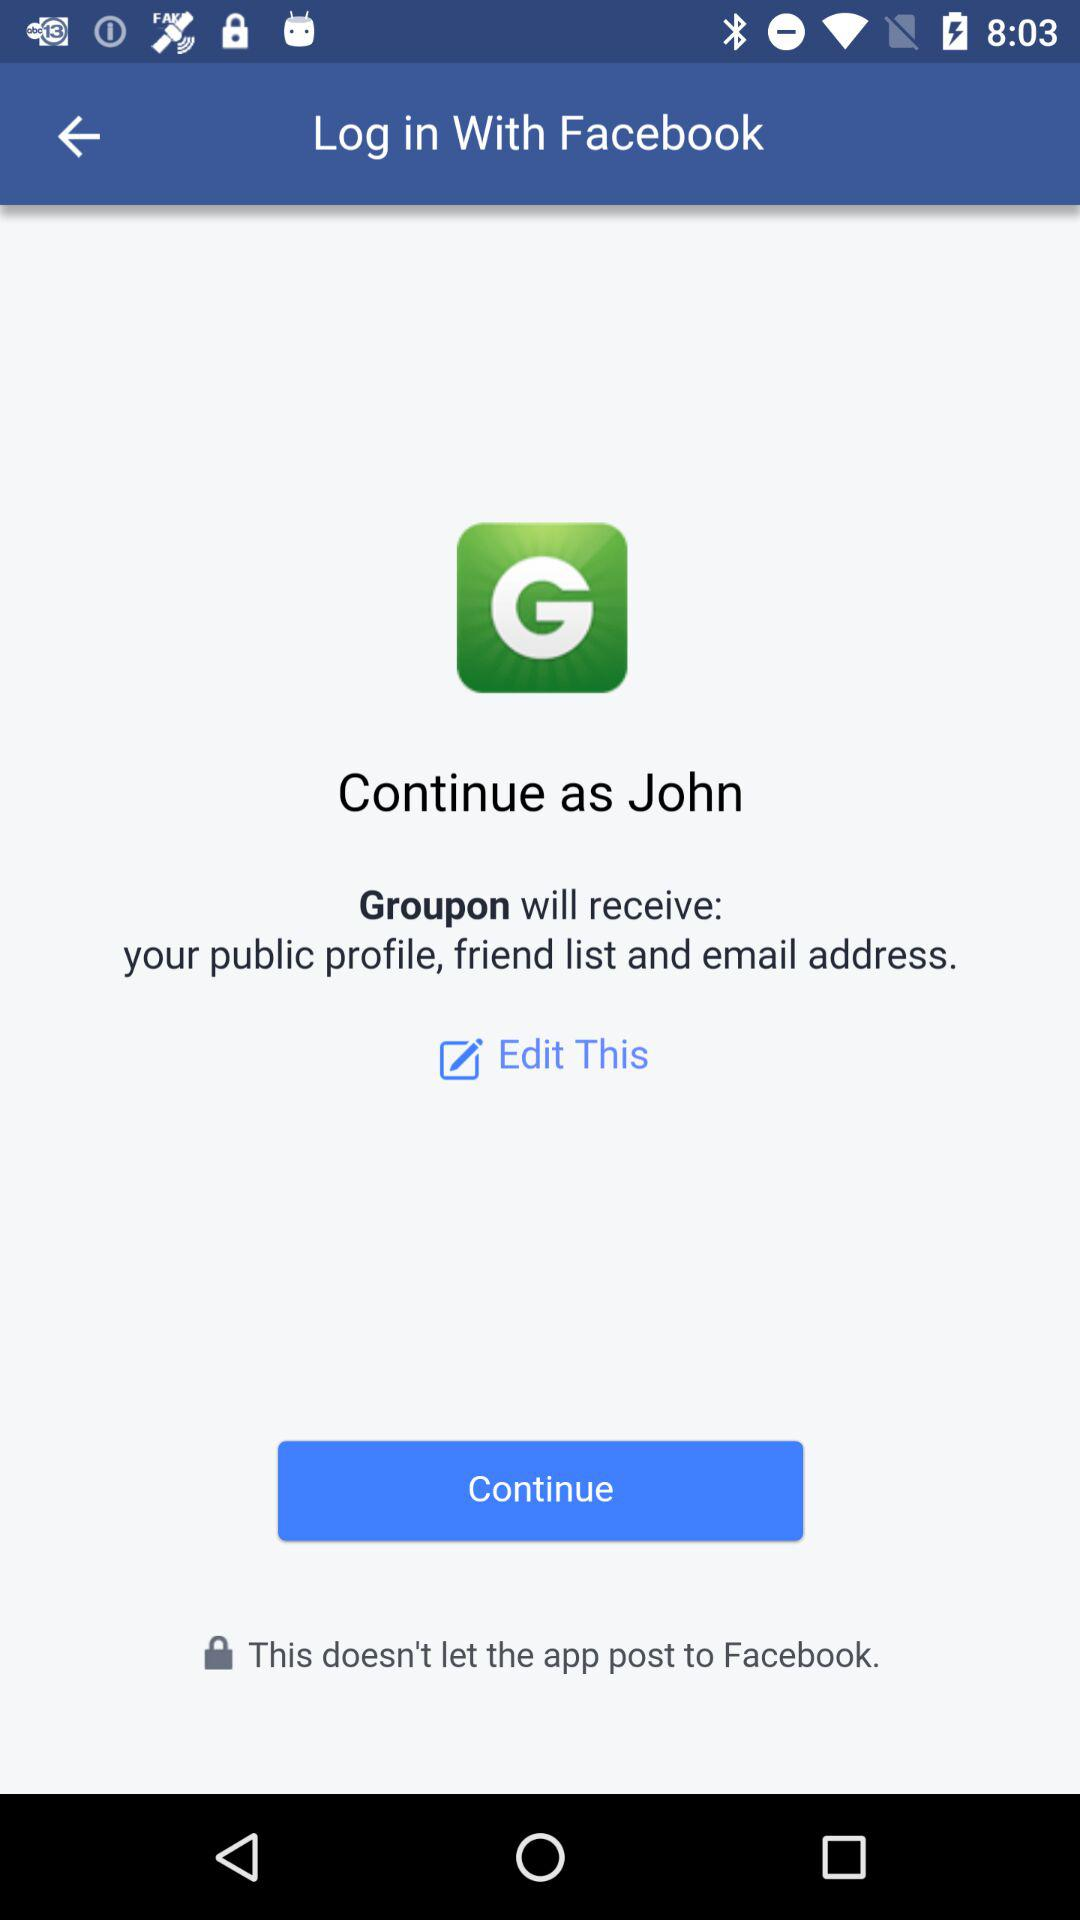What is the user name? The user name is John. 